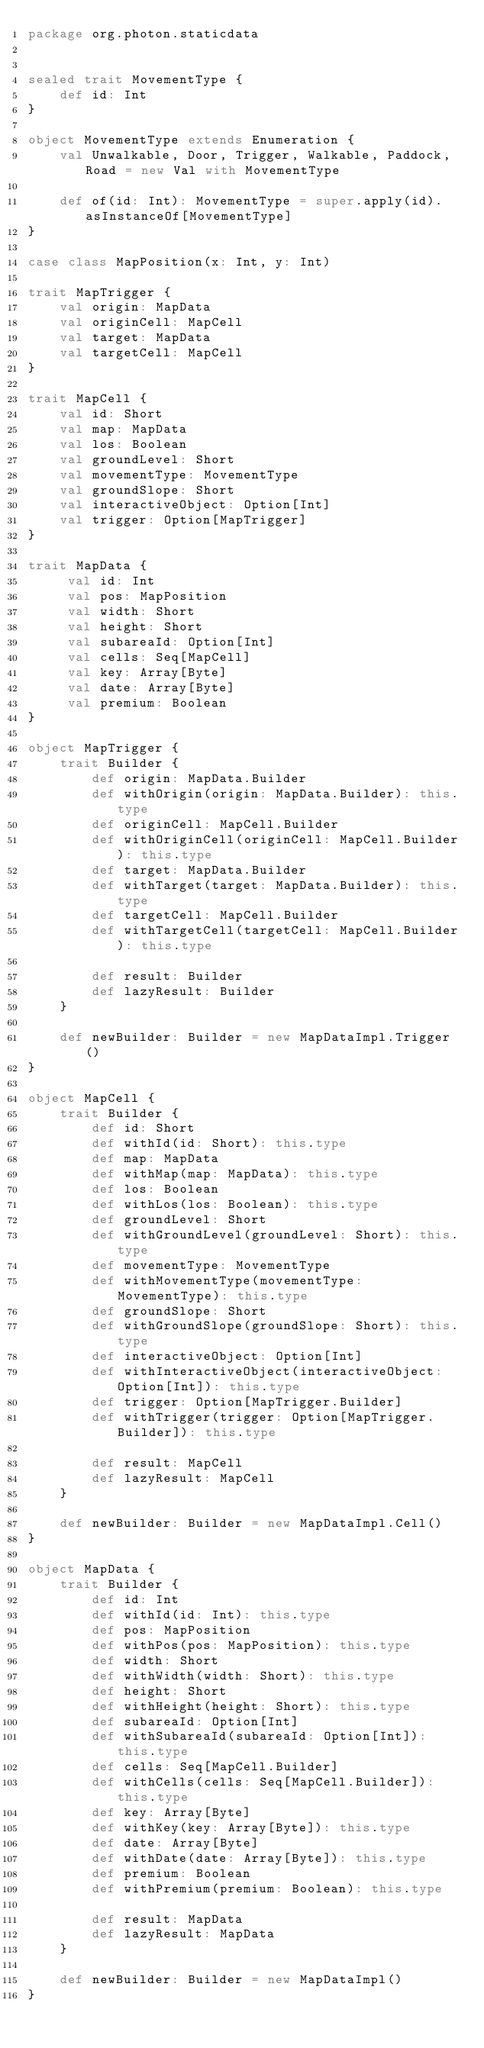<code> <loc_0><loc_0><loc_500><loc_500><_Scala_>package org.photon.staticdata


sealed trait MovementType {
	def id: Int
}

object MovementType extends Enumeration {
	val Unwalkable, Door, Trigger, Walkable, Paddock, Road = new Val with MovementType

	def of(id: Int): MovementType = super.apply(id).asInstanceOf[MovementType]
}

case class MapPosition(x: Int, y: Int)

trait MapTrigger {
	val origin: MapData
	val originCell: MapCell
	val target: MapData
	val targetCell: MapCell
}

trait MapCell {
	val id: Short
	val map: MapData
	val los: Boolean
	val groundLevel: Short
	val movementType: MovementType
	val groundSlope: Short
	val interactiveObject: Option[Int]
	val trigger: Option[MapTrigger]
}

trait MapData {
	 val id: Int
	 val pos: MapPosition
	 val width: Short
	 val height: Short
	 val subareaId: Option[Int]
	 val cells: Seq[MapCell]
	 val key: Array[Byte]
	 val date: Array[Byte]
	 val premium: Boolean
}

object MapTrigger {
	trait Builder {
		def origin: MapData.Builder
		def withOrigin(origin: MapData.Builder): this.type
		def originCell: MapCell.Builder
		def withOriginCell(originCell: MapCell.Builder): this.type
		def target: MapData.Builder
		def withTarget(target: MapData.Builder): this.type
		def targetCell: MapCell.Builder
		def withTargetCell(targetCell: MapCell.Builder): this.type

		def result: Builder
		def lazyResult: Builder
	}

	def newBuilder: Builder = new MapDataImpl.Trigger()
}

object MapCell {
	trait Builder {
		def id: Short
		def withId(id: Short): this.type
		def map: MapData
		def withMap(map: MapData): this.type
		def los: Boolean
		def withLos(los: Boolean): this.type
		def groundLevel: Short
		def withGroundLevel(groundLevel: Short): this.type
		def movementType: MovementType
		def withMovementType(movementType: MovementType): this.type
		def groundSlope: Short
		def withGroundSlope(groundSlope: Short): this.type
		def interactiveObject: Option[Int]
		def withInteractiveObject(interactiveObject: Option[Int]): this.type
		def trigger: Option[MapTrigger.Builder]
		def withTrigger(trigger: Option[MapTrigger.Builder]): this.type
		
		def result: MapCell
		def lazyResult: MapCell
	}
	
	def newBuilder: Builder = new MapDataImpl.Cell()
}

object MapData {
	trait Builder {
		def id: Int
		def withId(id: Int): this.type
		def pos: MapPosition
		def withPos(pos: MapPosition): this.type
		def width: Short
		def withWidth(width: Short): this.type
		def height: Short
		def withHeight(height: Short): this.type
		def subareaId: Option[Int]
		def withSubareaId(subareaId: Option[Int]): this.type
		def cells: Seq[MapCell.Builder]
		def withCells(cells: Seq[MapCell.Builder]): this.type
		def key: Array[Byte]
		def withKey(key: Array[Byte]): this.type
		def date: Array[Byte]
		def withDate(date: Array[Byte]): this.type
		def premium: Boolean
		def withPremium(premium: Boolean): this.type

		def result: MapData
		def lazyResult: MapData
	}

	def newBuilder: Builder = new MapDataImpl()
}
</code> 